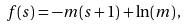<formula> <loc_0><loc_0><loc_500><loc_500>f ( s ) = - m ( s + 1 ) + \ln ( m ) \, ,</formula> 